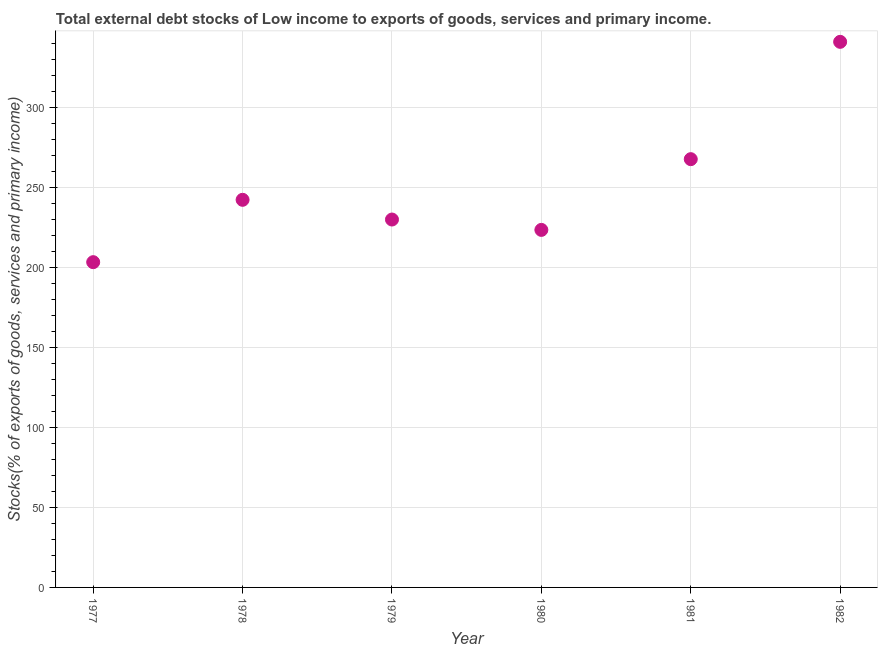What is the external debt stocks in 1977?
Make the answer very short. 203.26. Across all years, what is the maximum external debt stocks?
Make the answer very short. 340.95. Across all years, what is the minimum external debt stocks?
Give a very brief answer. 203.26. In which year was the external debt stocks maximum?
Ensure brevity in your answer.  1982. In which year was the external debt stocks minimum?
Make the answer very short. 1977. What is the sum of the external debt stocks?
Provide a short and direct response. 1507.41. What is the difference between the external debt stocks in 1979 and 1981?
Ensure brevity in your answer.  -37.72. What is the average external debt stocks per year?
Your answer should be compact. 251.24. What is the median external debt stocks?
Provide a succinct answer. 236.07. In how many years, is the external debt stocks greater than 160 %?
Your answer should be compact. 6. What is the ratio of the external debt stocks in 1977 to that in 1982?
Provide a short and direct response. 0.6. Is the external debt stocks in 1980 less than that in 1982?
Your response must be concise. Yes. Is the difference between the external debt stocks in 1979 and 1980 greater than the difference between any two years?
Your answer should be compact. No. What is the difference between the highest and the second highest external debt stocks?
Provide a short and direct response. 73.32. Is the sum of the external debt stocks in 1979 and 1982 greater than the maximum external debt stocks across all years?
Give a very brief answer. Yes. What is the difference between the highest and the lowest external debt stocks?
Ensure brevity in your answer.  137.69. How many years are there in the graph?
Ensure brevity in your answer.  6. Does the graph contain any zero values?
Keep it short and to the point. No. What is the title of the graph?
Give a very brief answer. Total external debt stocks of Low income to exports of goods, services and primary income. What is the label or title of the Y-axis?
Your answer should be compact. Stocks(% of exports of goods, services and primary income). What is the Stocks(% of exports of goods, services and primary income) in 1977?
Give a very brief answer. 203.26. What is the Stocks(% of exports of goods, services and primary income) in 1978?
Make the answer very short. 242.23. What is the Stocks(% of exports of goods, services and primary income) in 1979?
Keep it short and to the point. 229.91. What is the Stocks(% of exports of goods, services and primary income) in 1980?
Give a very brief answer. 223.43. What is the Stocks(% of exports of goods, services and primary income) in 1981?
Provide a short and direct response. 267.63. What is the Stocks(% of exports of goods, services and primary income) in 1982?
Give a very brief answer. 340.95. What is the difference between the Stocks(% of exports of goods, services and primary income) in 1977 and 1978?
Your answer should be very brief. -38.97. What is the difference between the Stocks(% of exports of goods, services and primary income) in 1977 and 1979?
Provide a short and direct response. -26.65. What is the difference between the Stocks(% of exports of goods, services and primary income) in 1977 and 1980?
Ensure brevity in your answer.  -20.17. What is the difference between the Stocks(% of exports of goods, services and primary income) in 1977 and 1981?
Give a very brief answer. -64.37. What is the difference between the Stocks(% of exports of goods, services and primary income) in 1977 and 1982?
Give a very brief answer. -137.69. What is the difference between the Stocks(% of exports of goods, services and primary income) in 1978 and 1979?
Ensure brevity in your answer.  12.32. What is the difference between the Stocks(% of exports of goods, services and primary income) in 1978 and 1980?
Give a very brief answer. 18.8. What is the difference between the Stocks(% of exports of goods, services and primary income) in 1978 and 1981?
Provide a succinct answer. -25.4. What is the difference between the Stocks(% of exports of goods, services and primary income) in 1978 and 1982?
Make the answer very short. -98.72. What is the difference between the Stocks(% of exports of goods, services and primary income) in 1979 and 1980?
Provide a short and direct response. 6.48. What is the difference between the Stocks(% of exports of goods, services and primary income) in 1979 and 1981?
Provide a succinct answer. -37.72. What is the difference between the Stocks(% of exports of goods, services and primary income) in 1979 and 1982?
Keep it short and to the point. -111.04. What is the difference between the Stocks(% of exports of goods, services and primary income) in 1980 and 1981?
Make the answer very short. -44.2. What is the difference between the Stocks(% of exports of goods, services and primary income) in 1980 and 1982?
Offer a terse response. -117.52. What is the difference between the Stocks(% of exports of goods, services and primary income) in 1981 and 1982?
Offer a terse response. -73.32. What is the ratio of the Stocks(% of exports of goods, services and primary income) in 1977 to that in 1978?
Your answer should be compact. 0.84. What is the ratio of the Stocks(% of exports of goods, services and primary income) in 1977 to that in 1979?
Your answer should be very brief. 0.88. What is the ratio of the Stocks(% of exports of goods, services and primary income) in 1977 to that in 1980?
Give a very brief answer. 0.91. What is the ratio of the Stocks(% of exports of goods, services and primary income) in 1977 to that in 1981?
Your answer should be compact. 0.76. What is the ratio of the Stocks(% of exports of goods, services and primary income) in 1977 to that in 1982?
Your answer should be compact. 0.6. What is the ratio of the Stocks(% of exports of goods, services and primary income) in 1978 to that in 1979?
Give a very brief answer. 1.05. What is the ratio of the Stocks(% of exports of goods, services and primary income) in 1978 to that in 1980?
Your response must be concise. 1.08. What is the ratio of the Stocks(% of exports of goods, services and primary income) in 1978 to that in 1981?
Keep it short and to the point. 0.91. What is the ratio of the Stocks(% of exports of goods, services and primary income) in 1978 to that in 1982?
Your answer should be very brief. 0.71. What is the ratio of the Stocks(% of exports of goods, services and primary income) in 1979 to that in 1980?
Give a very brief answer. 1.03. What is the ratio of the Stocks(% of exports of goods, services and primary income) in 1979 to that in 1981?
Your response must be concise. 0.86. What is the ratio of the Stocks(% of exports of goods, services and primary income) in 1979 to that in 1982?
Your response must be concise. 0.67. What is the ratio of the Stocks(% of exports of goods, services and primary income) in 1980 to that in 1981?
Your answer should be compact. 0.83. What is the ratio of the Stocks(% of exports of goods, services and primary income) in 1980 to that in 1982?
Your answer should be very brief. 0.66. What is the ratio of the Stocks(% of exports of goods, services and primary income) in 1981 to that in 1982?
Offer a terse response. 0.79. 